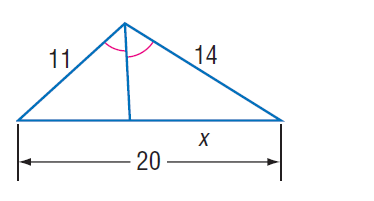Question: Find x.
Choices:
A. 10
B. 11
C. \frac { 56 } { 5 }
D. 12
Answer with the letter. Answer: C 